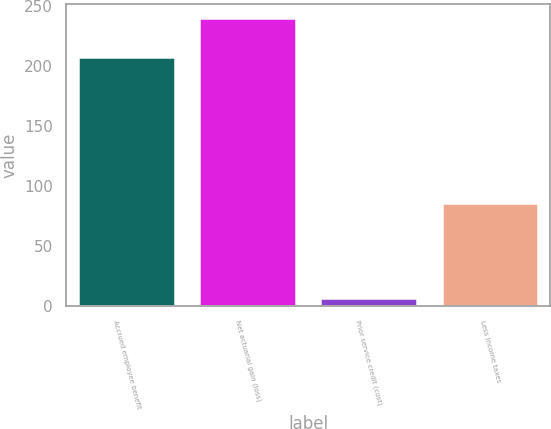<chart> <loc_0><loc_0><loc_500><loc_500><bar_chart><fcel>Accrued employee benefit<fcel>Net actuarial gain (loss)<fcel>Prior service credit (cost)<fcel>Less Income taxes<nl><fcel>208<fcel>240<fcel>7<fcel>86<nl></chart> 